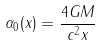Convert formula to latex. <formula><loc_0><loc_0><loc_500><loc_500>\alpha _ { 0 } ( x ) = \frac { 4 G M } { c ^ { 2 } x }</formula> 